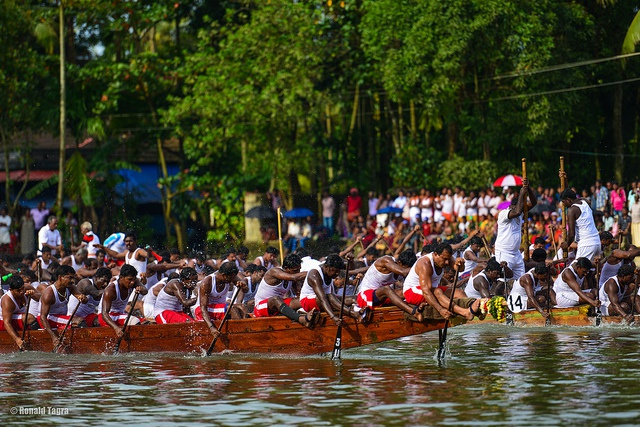Describe the objects in this image and their specific colors. I can see people in darkgreen, black, maroon, gray, and lavender tones, boat in darkgreen, maroon, black, and gray tones, people in darkgreen, black, maroon, lavender, and salmon tones, people in darkgreen, black, maroon, lavender, and brown tones, and people in darkgreen, black, maroon, brown, and gray tones in this image. 